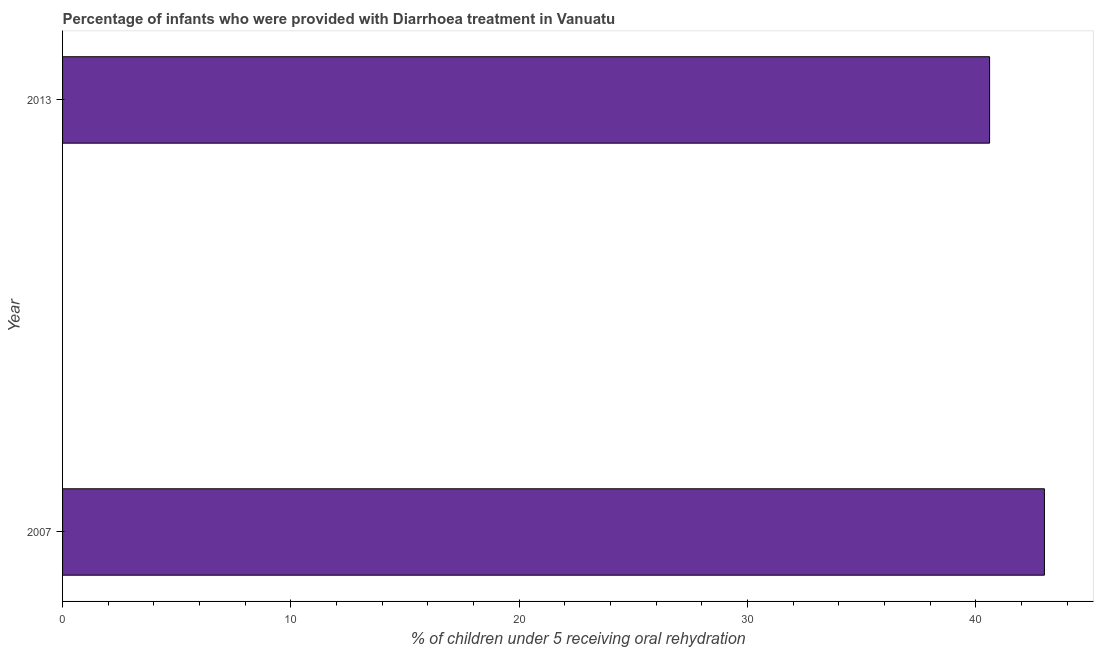Does the graph contain any zero values?
Offer a terse response. No. Does the graph contain grids?
Provide a succinct answer. No. What is the title of the graph?
Ensure brevity in your answer.  Percentage of infants who were provided with Diarrhoea treatment in Vanuatu. What is the label or title of the X-axis?
Your answer should be very brief. % of children under 5 receiving oral rehydration. What is the label or title of the Y-axis?
Give a very brief answer. Year. What is the percentage of children who were provided with treatment diarrhoea in 2007?
Make the answer very short. 43. Across all years, what is the minimum percentage of children who were provided with treatment diarrhoea?
Your response must be concise. 40.6. In which year was the percentage of children who were provided with treatment diarrhoea minimum?
Your answer should be compact. 2013. What is the sum of the percentage of children who were provided with treatment diarrhoea?
Your answer should be compact. 83.6. What is the difference between the percentage of children who were provided with treatment diarrhoea in 2007 and 2013?
Provide a succinct answer. 2.4. What is the average percentage of children who were provided with treatment diarrhoea per year?
Your answer should be compact. 41.8. What is the median percentage of children who were provided with treatment diarrhoea?
Your answer should be very brief. 41.8. Do a majority of the years between 2007 and 2013 (inclusive) have percentage of children who were provided with treatment diarrhoea greater than 30 %?
Offer a terse response. Yes. What is the ratio of the percentage of children who were provided with treatment diarrhoea in 2007 to that in 2013?
Your response must be concise. 1.06. Is the percentage of children who were provided with treatment diarrhoea in 2007 less than that in 2013?
Your response must be concise. No. In how many years, is the percentage of children who were provided with treatment diarrhoea greater than the average percentage of children who were provided with treatment diarrhoea taken over all years?
Your response must be concise. 1. What is the % of children under 5 receiving oral rehydration of 2007?
Keep it short and to the point. 43. What is the % of children under 5 receiving oral rehydration in 2013?
Give a very brief answer. 40.6. What is the ratio of the % of children under 5 receiving oral rehydration in 2007 to that in 2013?
Ensure brevity in your answer.  1.06. 